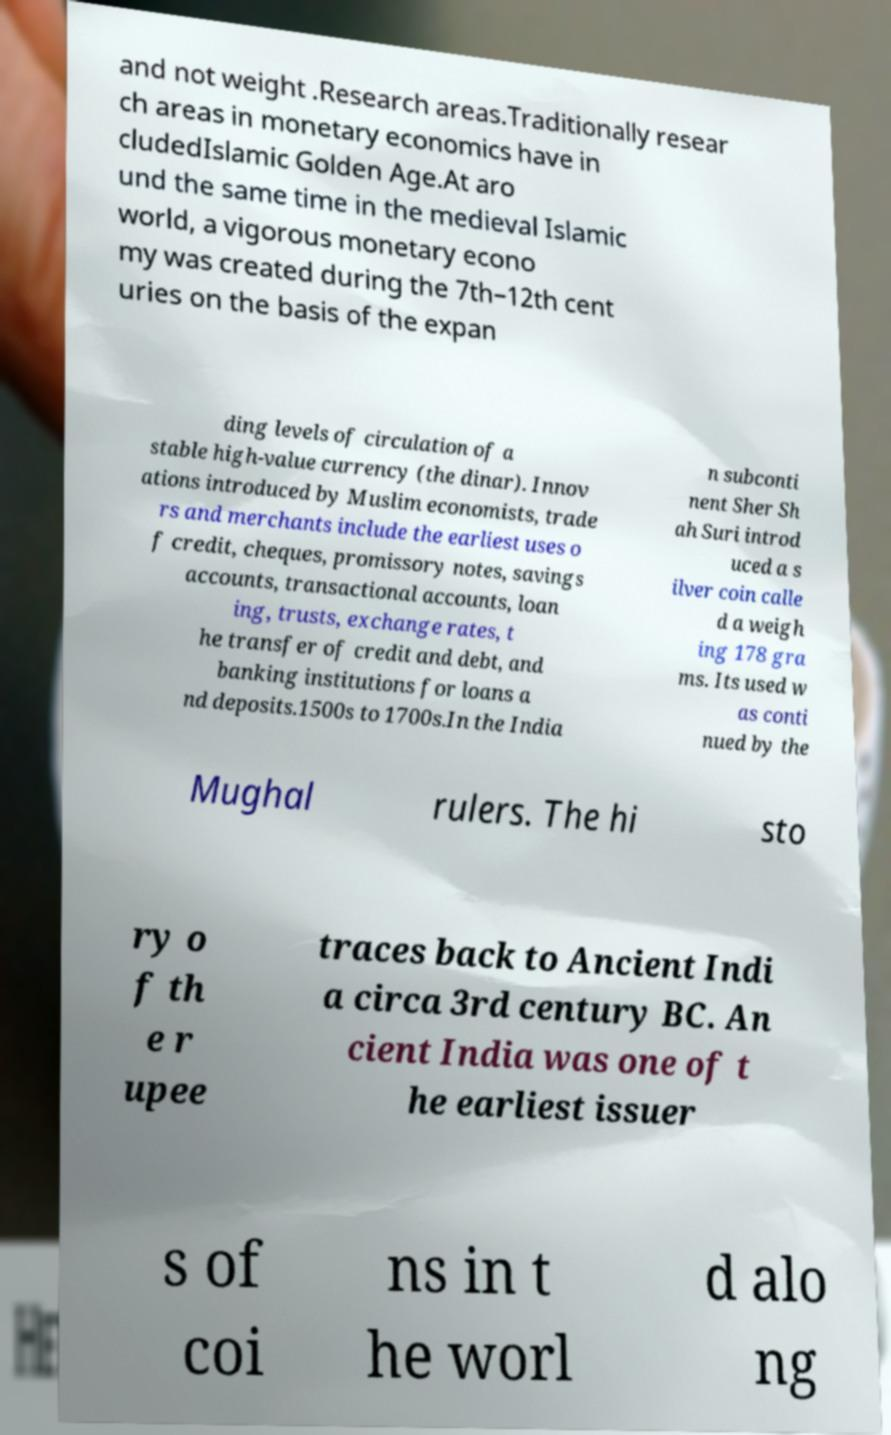Can you read and provide the text displayed in the image?This photo seems to have some interesting text. Can you extract and type it out for me? and not weight .Research areas.Traditionally resear ch areas in monetary economics have in cludedIslamic Golden Age.At aro und the same time in the medieval Islamic world, a vigorous monetary econo my was created during the 7th–12th cent uries on the basis of the expan ding levels of circulation of a stable high-value currency (the dinar). Innov ations introduced by Muslim economists, trade rs and merchants include the earliest uses o f credit, cheques, promissory notes, savings accounts, transactional accounts, loan ing, trusts, exchange rates, t he transfer of credit and debt, and banking institutions for loans a nd deposits.1500s to 1700s.In the India n subconti nent Sher Sh ah Suri introd uced a s ilver coin calle d a weigh ing 178 gra ms. Its used w as conti nued by the Mughal rulers. The hi sto ry o f th e r upee traces back to Ancient Indi a circa 3rd century BC. An cient India was one of t he earliest issuer s of coi ns in t he worl d alo ng 